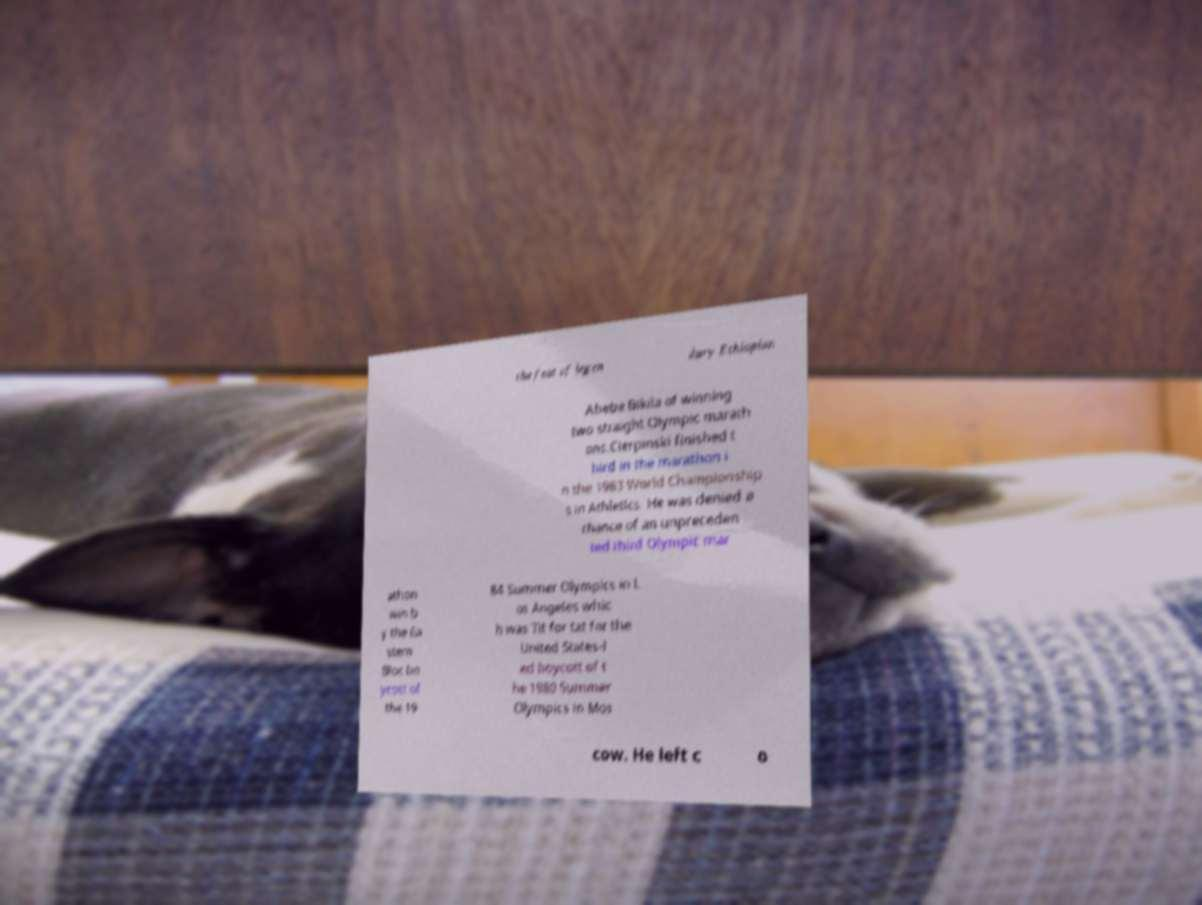Please identify and transcribe the text found in this image. the feat of legen dary Ethiopian Abebe Bikila of winning two straight Olympic marath ons.Cierpinski finished t hird in the marathon i n the 1983 World Championship s in Athletics. He was denied a chance of an unpreceden ted third Olympic mar athon win b y the Ea stern Bloc bo ycott of the 19 84 Summer Olympics in L os Angeles whic h was Tit for tat for the United States-l ed boycott of t he 1980 Summer Olympics in Mos cow. He left c o 